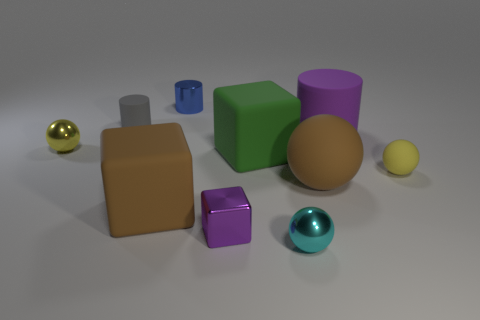What is the shape of the matte object that is the same color as the tiny cube?
Provide a succinct answer. Cylinder. There is a cylinder that is the same color as the metal block; what is its size?
Keep it short and to the point. Large. There is a tiny thing that is the same color as the large cylinder; what is it made of?
Provide a succinct answer. Metal. Do the big cylinder and the tiny sphere on the right side of the cyan ball have the same color?
Your answer should be very brief. No. There is a metal thing that is both behind the green rubber object and to the right of the tiny gray matte cylinder; what size is it?
Provide a succinct answer. Small. How many other objects are the same color as the metal cube?
Your answer should be compact. 1. What size is the yellow thing in front of the big rubber block that is behind the large rubber block in front of the big brown sphere?
Offer a very short reply. Small. There is a tiny metal cylinder; are there any tiny cylinders on the left side of it?
Offer a very short reply. Yes. There is a gray matte thing; is it the same size as the yellow object that is left of the gray object?
Your answer should be compact. Yes. What number of other things are made of the same material as the small gray cylinder?
Offer a terse response. 5. 